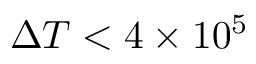<formula> <loc_0><loc_0><loc_500><loc_500>\Delta T < 4 \times 1 0 ^ { 5 }</formula> 